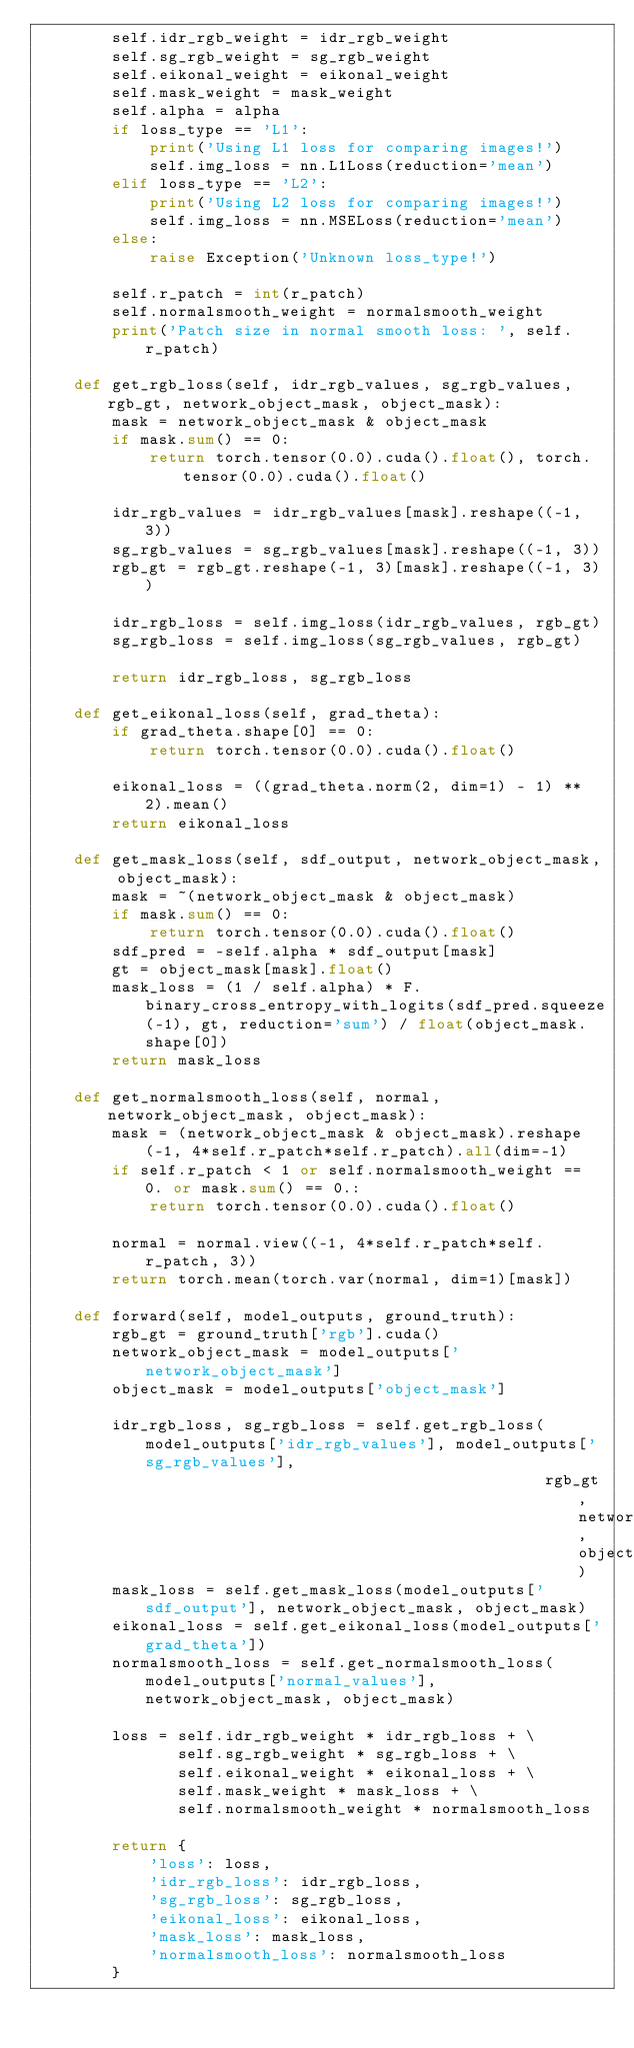<code> <loc_0><loc_0><loc_500><loc_500><_Python_>        self.idr_rgb_weight = idr_rgb_weight
        self.sg_rgb_weight = sg_rgb_weight
        self.eikonal_weight = eikonal_weight
        self.mask_weight = mask_weight
        self.alpha = alpha
        if loss_type == 'L1':
            print('Using L1 loss for comparing images!')
            self.img_loss = nn.L1Loss(reduction='mean')
        elif loss_type == 'L2':
            print('Using L2 loss for comparing images!')
            self.img_loss = nn.MSELoss(reduction='mean')
        else:
            raise Exception('Unknown loss_type!')

        self.r_patch = int(r_patch)
        self.normalsmooth_weight = normalsmooth_weight
        print('Patch size in normal smooth loss: ', self.r_patch)

    def get_rgb_loss(self, idr_rgb_values, sg_rgb_values, rgb_gt, network_object_mask, object_mask):
        mask = network_object_mask & object_mask
        if mask.sum() == 0:
            return torch.tensor(0.0).cuda().float(), torch.tensor(0.0).cuda().float()

        idr_rgb_values = idr_rgb_values[mask].reshape((-1, 3))
        sg_rgb_values = sg_rgb_values[mask].reshape((-1, 3))
        rgb_gt = rgb_gt.reshape(-1, 3)[mask].reshape((-1, 3))

        idr_rgb_loss = self.img_loss(idr_rgb_values, rgb_gt)
        sg_rgb_loss = self.img_loss(sg_rgb_values, rgb_gt)

        return idr_rgb_loss, sg_rgb_loss

    def get_eikonal_loss(self, grad_theta):
        if grad_theta.shape[0] == 0:
            return torch.tensor(0.0).cuda().float()

        eikonal_loss = ((grad_theta.norm(2, dim=1) - 1) ** 2).mean()
        return eikonal_loss

    def get_mask_loss(self, sdf_output, network_object_mask, object_mask):
        mask = ~(network_object_mask & object_mask)
        if mask.sum() == 0:
            return torch.tensor(0.0).cuda().float()
        sdf_pred = -self.alpha * sdf_output[mask]
        gt = object_mask[mask].float()
        mask_loss = (1 / self.alpha) * F.binary_cross_entropy_with_logits(sdf_pred.squeeze(-1), gt, reduction='sum') / float(object_mask.shape[0])
        return mask_loss

    def get_normalsmooth_loss(self, normal, network_object_mask, object_mask):
        mask = (network_object_mask & object_mask).reshape(-1, 4*self.r_patch*self.r_patch).all(dim=-1)
        if self.r_patch < 1 or self.normalsmooth_weight == 0. or mask.sum() == 0.:
            return torch.tensor(0.0).cuda().float()

        normal = normal.view((-1, 4*self.r_patch*self.r_patch, 3))
        return torch.mean(torch.var(normal, dim=1)[mask])

    def forward(self, model_outputs, ground_truth):
        rgb_gt = ground_truth['rgb'].cuda()
        network_object_mask = model_outputs['network_object_mask']
        object_mask = model_outputs['object_mask']

        idr_rgb_loss, sg_rgb_loss = self.get_rgb_loss(model_outputs['idr_rgb_values'], model_outputs['sg_rgb_values'],
                                                      rgb_gt, network_object_mask, object_mask)
        mask_loss = self.get_mask_loss(model_outputs['sdf_output'], network_object_mask, object_mask)
        eikonal_loss = self.get_eikonal_loss(model_outputs['grad_theta'])
        normalsmooth_loss = self.get_normalsmooth_loss(model_outputs['normal_values'], network_object_mask, object_mask)

        loss = self.idr_rgb_weight * idr_rgb_loss + \
               self.sg_rgb_weight * sg_rgb_loss + \
               self.eikonal_weight * eikonal_loss + \
               self.mask_weight * mask_loss + \
               self.normalsmooth_weight * normalsmooth_loss

        return {
            'loss': loss,
            'idr_rgb_loss': idr_rgb_loss,
            'sg_rgb_loss': sg_rgb_loss,
            'eikonal_loss': eikonal_loss,
            'mask_loss': mask_loss,
            'normalsmooth_loss': normalsmooth_loss
        }
</code> 